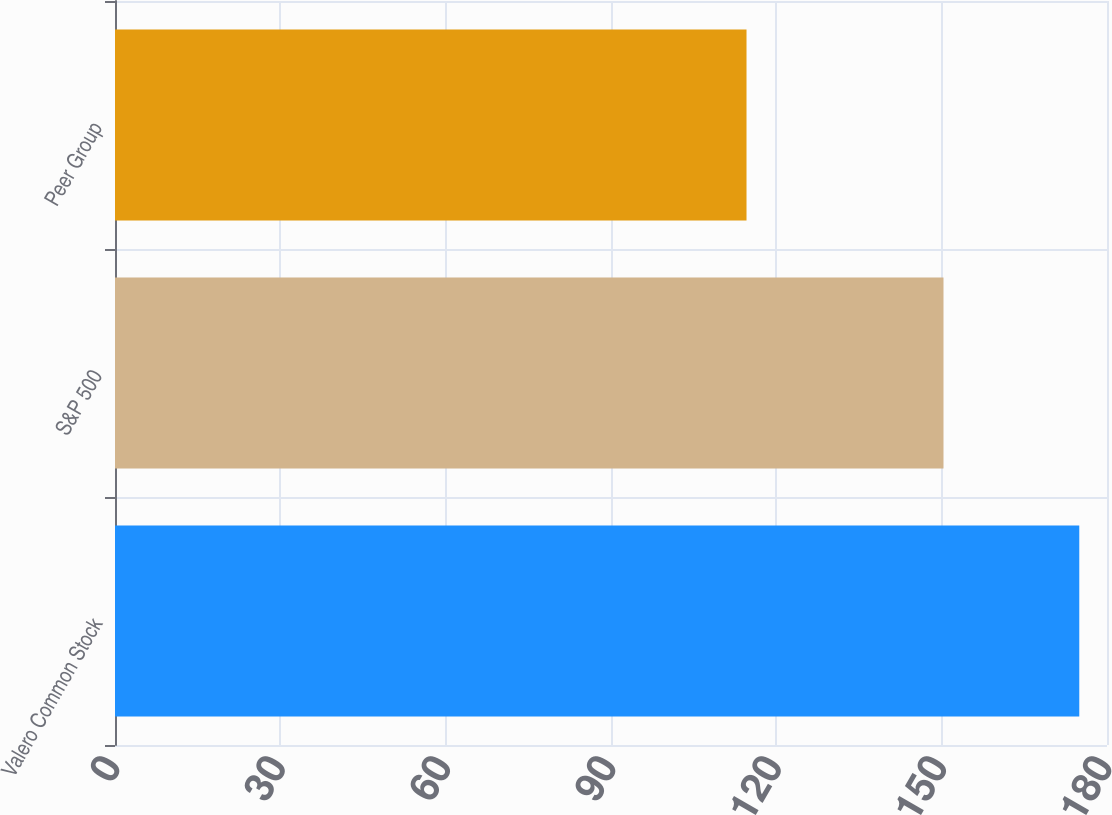Convert chart. <chart><loc_0><loc_0><loc_500><loc_500><bar_chart><fcel>Valero Common Stock<fcel>S&P 500<fcel>Peer Group<nl><fcel>174.97<fcel>150.33<fcel>114.59<nl></chart> 